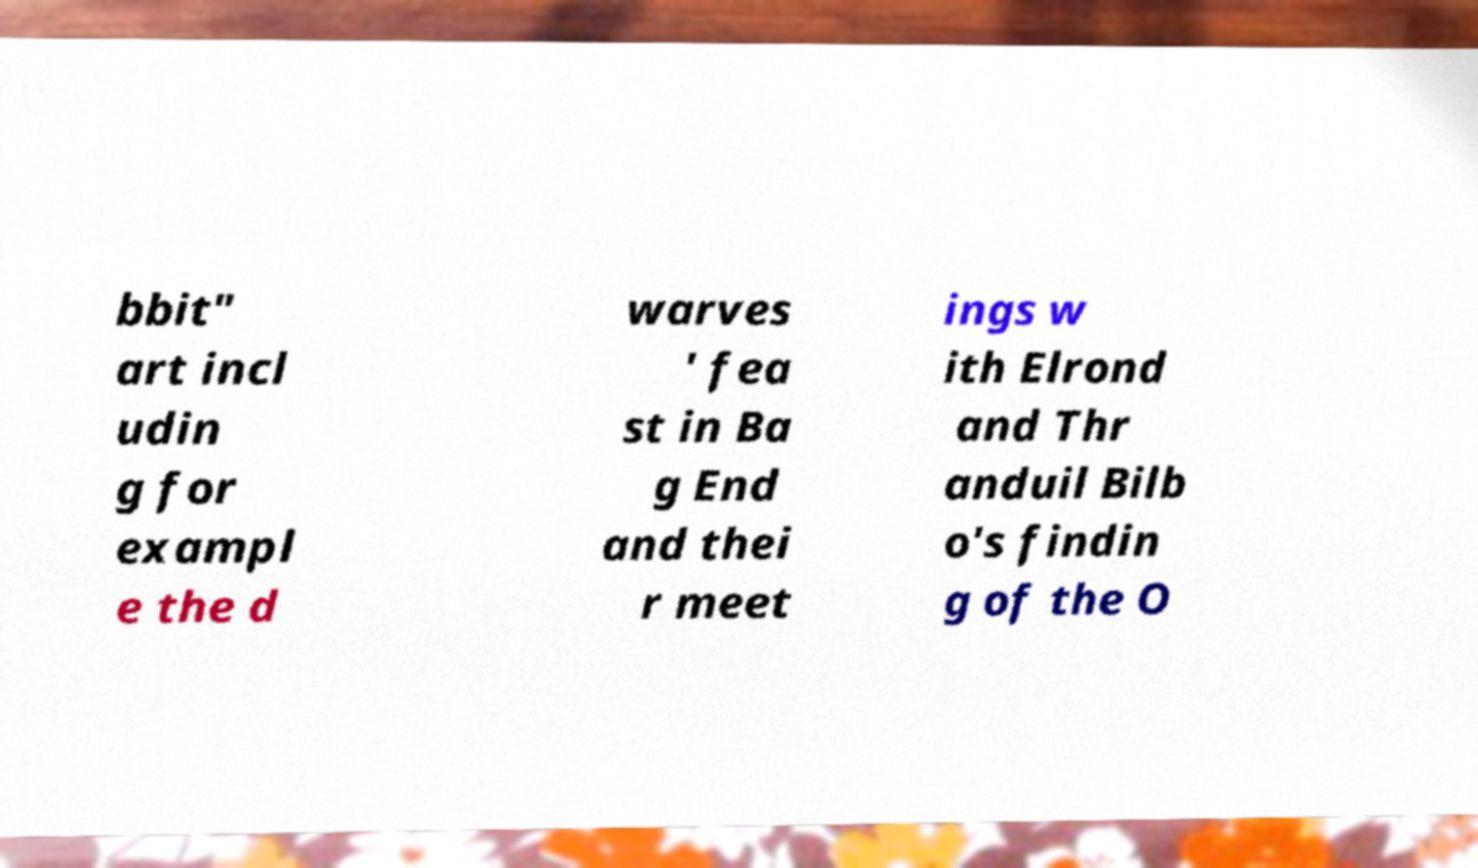For documentation purposes, I need the text within this image transcribed. Could you provide that? bbit" art incl udin g for exampl e the d warves ' fea st in Ba g End and thei r meet ings w ith Elrond and Thr anduil Bilb o's findin g of the O 